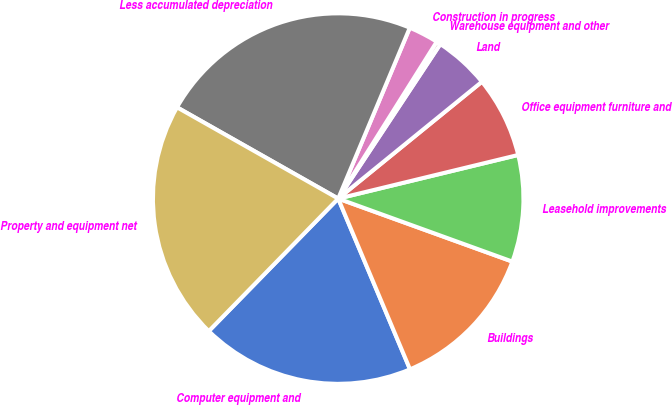Convert chart to OTSL. <chart><loc_0><loc_0><loc_500><loc_500><pie_chart><fcel>Computer equipment and<fcel>Buildings<fcel>Leasehold improvements<fcel>Office equipment furniture and<fcel>Land<fcel>Warehouse equipment and other<fcel>Construction in progress<fcel>Less accumulated depreciation<fcel>Property and equipment net<nl><fcel>18.65%<fcel>13.14%<fcel>9.31%<fcel>7.08%<fcel>4.84%<fcel>0.37%<fcel>2.61%<fcel>23.12%<fcel>20.89%<nl></chart> 